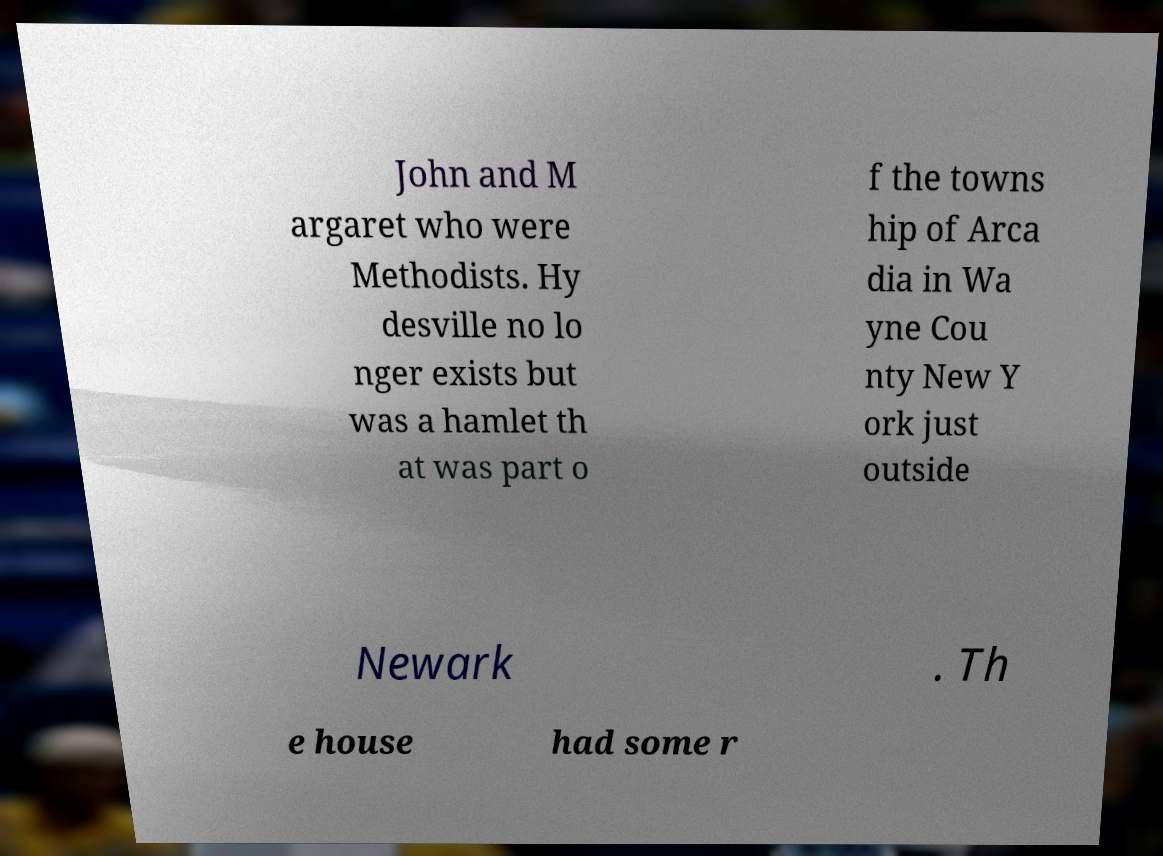Please read and relay the text visible in this image. What does it say? John and M argaret who were Methodists. Hy desville no lo nger exists but was a hamlet th at was part o f the towns hip of Arca dia in Wa yne Cou nty New Y ork just outside Newark . Th e house had some r 